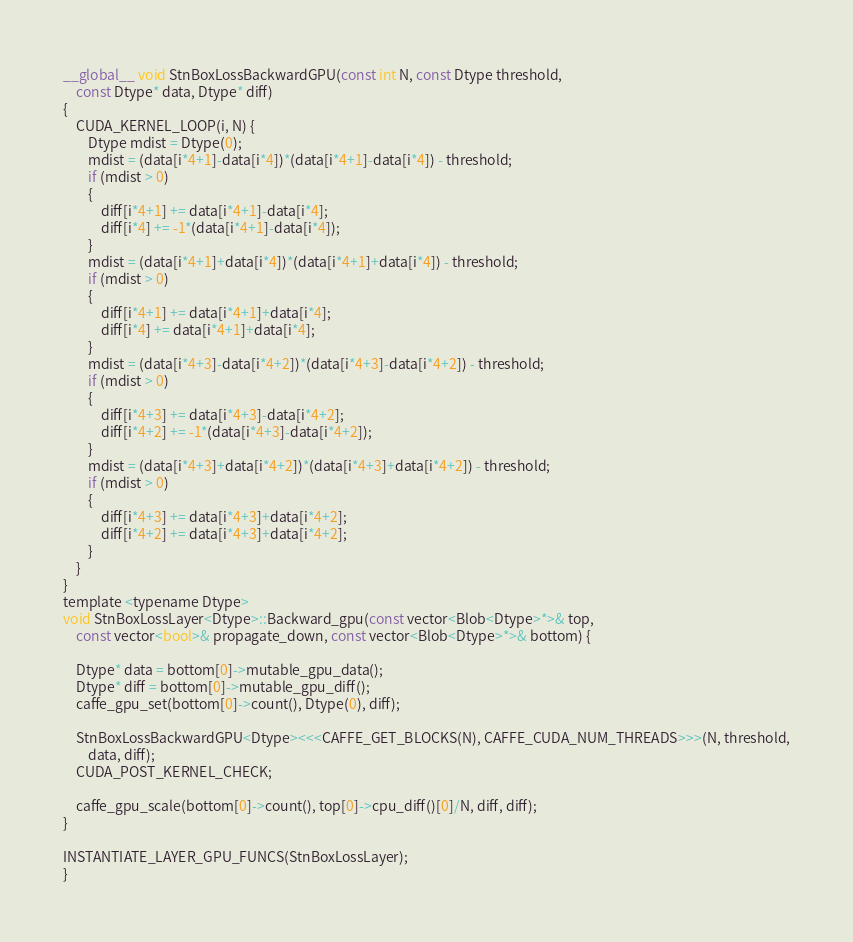<code> <loc_0><loc_0><loc_500><loc_500><_Cuda_>__global__ void StnBoxLossBackwardGPU(const int N, const Dtype threshold,  
    const Dtype* data, Dtype* diff)
{
    CUDA_KERNEL_LOOP(i, N) {
        Dtype mdist = Dtype(0);
        mdist = (data[i*4+1]-data[i*4])*(data[i*4+1]-data[i*4]) - threshold;
        if (mdist > 0)
        {
            diff[i*4+1] += data[i*4+1]-data[i*4];
            diff[i*4] += -1*(data[i*4+1]-data[i*4]);
        }
        mdist = (data[i*4+1]+data[i*4])*(data[i*4+1]+data[i*4]) - threshold;
        if (mdist > 0)
        {
            diff[i*4+1] += data[i*4+1]+data[i*4];
            diff[i*4] += data[i*4+1]+data[i*4];
        }
        mdist = (data[i*4+3]-data[i*4+2])*(data[i*4+3]-data[i*4+2]) - threshold;
        if (mdist > 0)
        {
            diff[i*4+3] += data[i*4+3]-data[i*4+2];
            diff[i*4+2] += -1*(data[i*4+3]-data[i*4+2]);
        }
        mdist = (data[i*4+3]+data[i*4+2])*(data[i*4+3]+data[i*4+2]) - threshold;
        if (mdist > 0)
        {
            diff[i*4+3] += data[i*4+3]+data[i*4+2];
            diff[i*4+2] += data[i*4+3]+data[i*4+2];
        }
    }
}
template <typename Dtype>
void StnBoxLossLayer<Dtype>::Backward_gpu(const vector<Blob<Dtype>*>& top,
    const vector<bool>& propagate_down, const vector<Blob<Dtype>*>& bottom) {
    
    Dtype* data = bottom[0]->mutable_gpu_data();
    Dtype* diff = bottom[0]->mutable_gpu_diff();
    caffe_gpu_set(bottom[0]->count(), Dtype(0), diff);

    StnBoxLossBackwardGPU<Dtype><<<CAFFE_GET_BLOCKS(N), CAFFE_CUDA_NUM_THREADS>>>(N, threshold,
        data, diff); 
    CUDA_POST_KERNEL_CHECK;

    caffe_gpu_scale(bottom[0]->count(), top[0]->cpu_diff()[0]/N, diff, diff);
}

INSTANTIATE_LAYER_GPU_FUNCS(StnBoxLossLayer);
}
</code> 